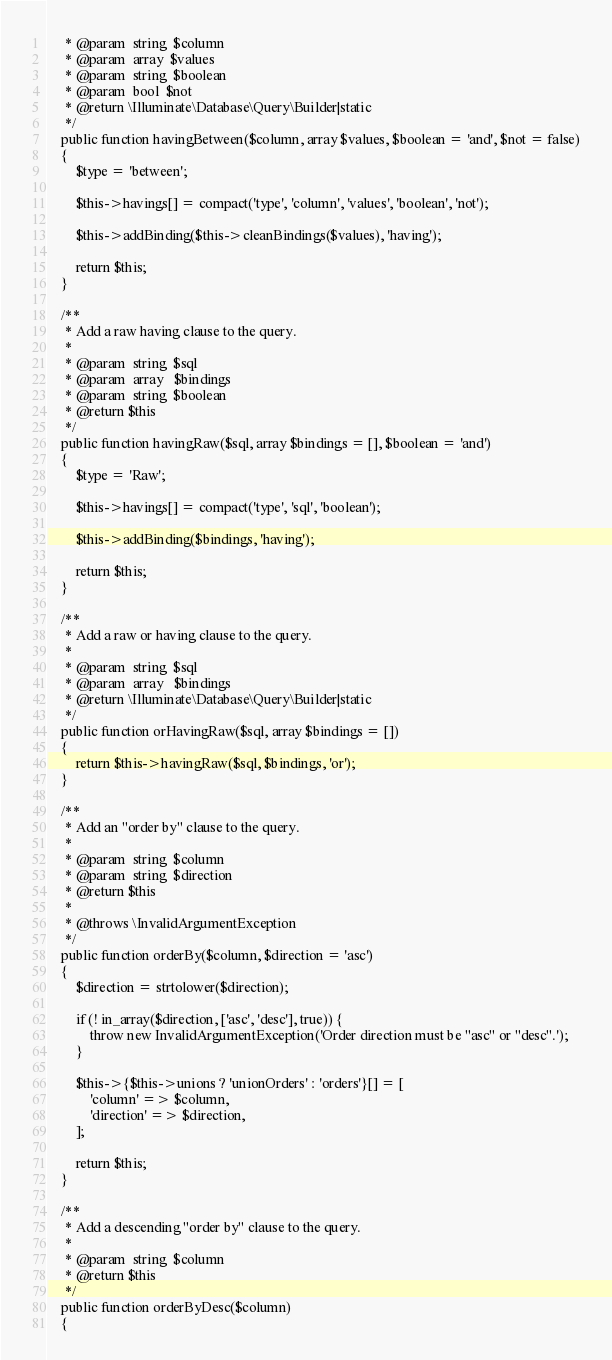Convert code to text. <code><loc_0><loc_0><loc_500><loc_500><_PHP_>     * @param  string  $column
     * @param  array  $values
     * @param  string  $boolean
     * @param  bool  $not
     * @return \Illuminate\Database\Query\Builder|static
     */
    public function havingBetween($column, array $values, $boolean = 'and', $not = false)
    {
        $type = 'between';

        $this->havings[] = compact('type', 'column', 'values', 'boolean', 'not');

        $this->addBinding($this->cleanBindings($values), 'having');

        return $this;
    }

    /**
     * Add a raw having clause to the query.
     *
     * @param  string  $sql
     * @param  array   $bindings
     * @param  string  $boolean
     * @return $this
     */
    public function havingRaw($sql, array $bindings = [], $boolean = 'and')
    {
        $type = 'Raw';

        $this->havings[] = compact('type', 'sql', 'boolean');

        $this->addBinding($bindings, 'having');

        return $this;
    }

    /**
     * Add a raw or having clause to the query.
     *
     * @param  string  $sql
     * @param  array   $bindings
     * @return \Illuminate\Database\Query\Builder|static
     */
    public function orHavingRaw($sql, array $bindings = [])
    {
        return $this->havingRaw($sql, $bindings, 'or');
    }

    /**
     * Add an "order by" clause to the query.
     *
     * @param  string  $column
     * @param  string  $direction
     * @return $this
     *
     * @throws \InvalidArgumentException
     */
    public function orderBy($column, $direction = 'asc')
    {
        $direction = strtolower($direction);

        if (! in_array($direction, ['asc', 'desc'], true)) {
            throw new InvalidArgumentException('Order direction must be "asc" or "desc".');
        }

        $this->{$this->unions ? 'unionOrders' : 'orders'}[] = [
            'column' => $column,
            'direction' => $direction,
        ];

        return $this;
    }

    /**
     * Add a descending "order by" clause to the query.
     *
     * @param  string  $column
     * @return $this
     */
    public function orderByDesc($column)
    {</code> 